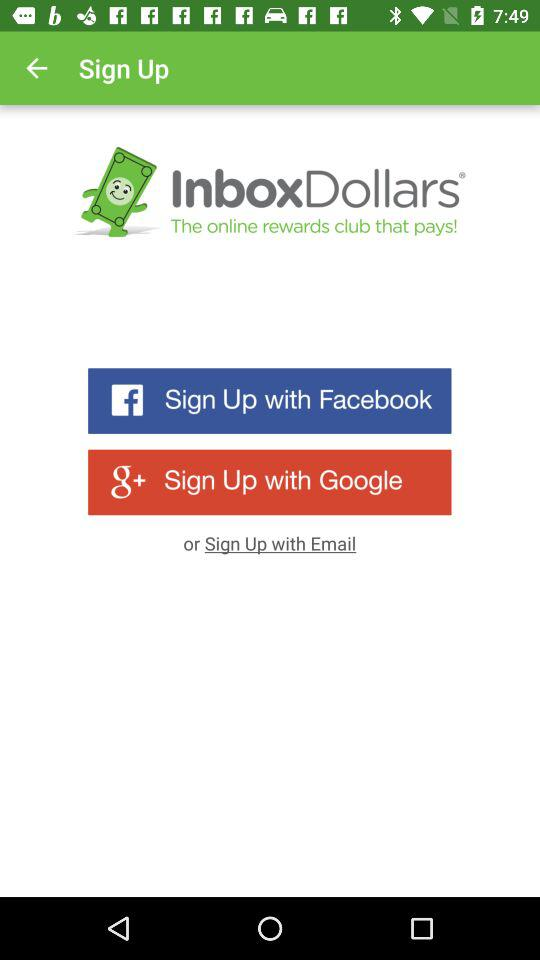How many more social media sign up options are there than email sign up options?
Answer the question using a single word or phrase. 2 